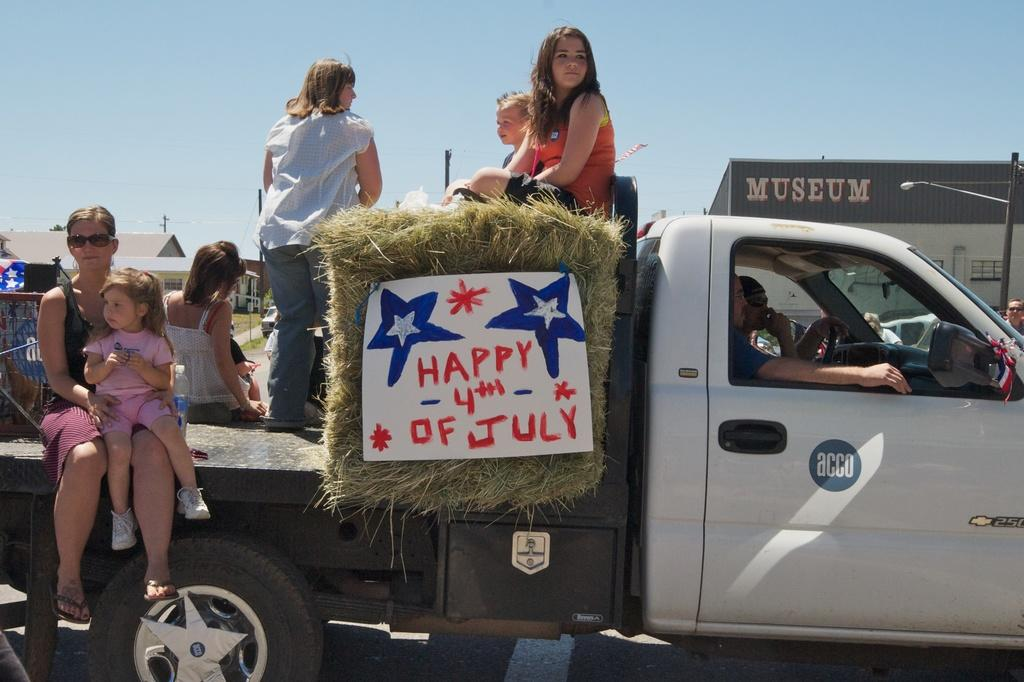What is the main subject of the image? The main subject of the image is a group of people. Where are the people located in the image? The people are sitting on a truck. Can you describe the woman in the image? There is a woman in the image, and she is standing. What type of bait is being used by the woman in the image? There is no bait present in the image, as it features a group of people sitting on a truck and a woman standing nearby. 